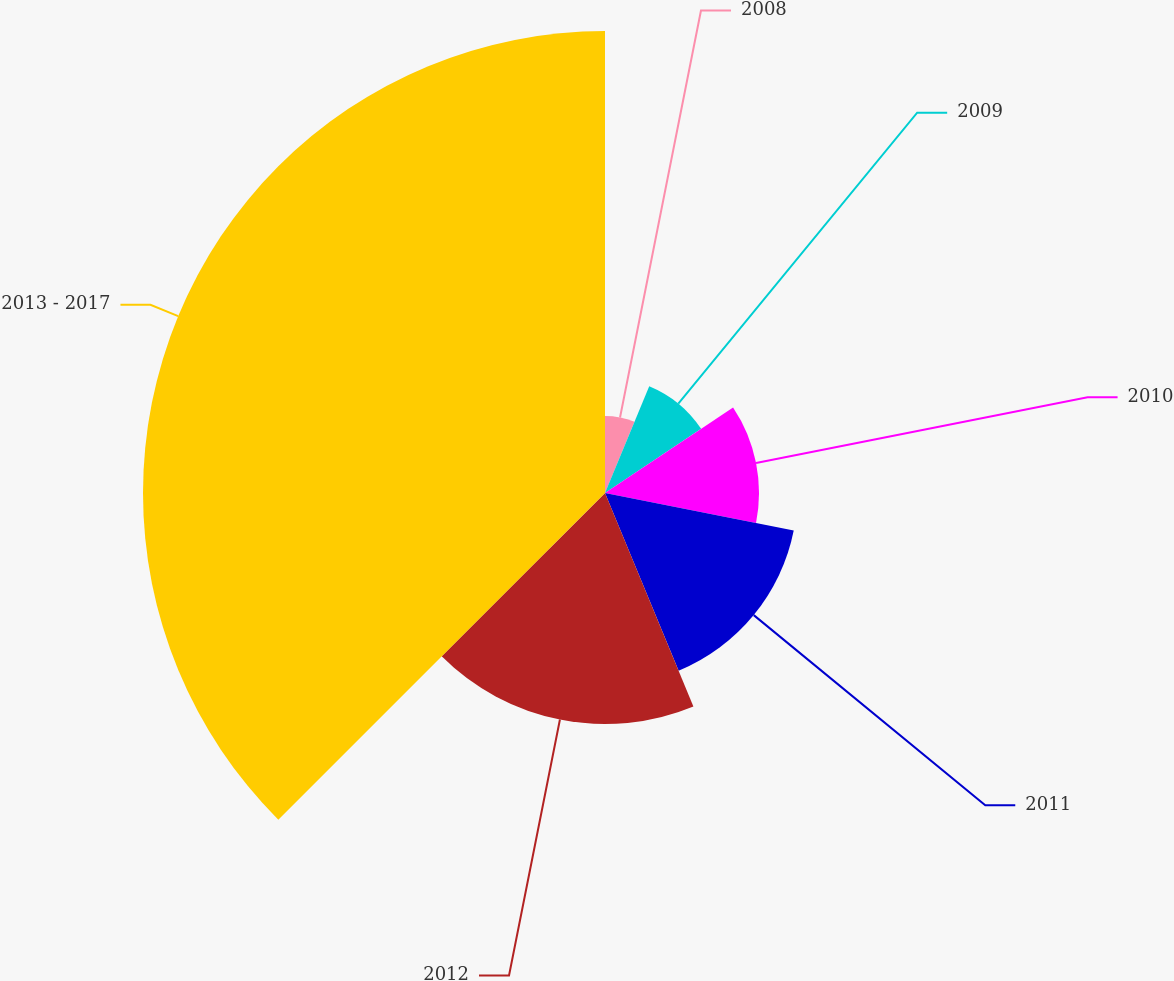<chart> <loc_0><loc_0><loc_500><loc_500><pie_chart><fcel>2008<fcel>2009<fcel>2010<fcel>2011<fcel>2012<fcel>2013 - 2017<nl><fcel>6.25%<fcel>9.38%<fcel>12.5%<fcel>15.62%<fcel>18.75%<fcel>37.5%<nl></chart> 